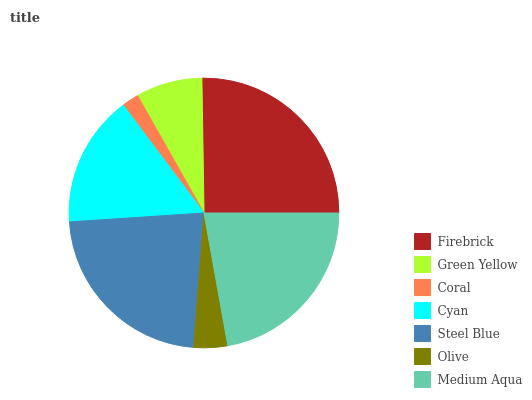Is Coral the minimum?
Answer yes or no. Yes. Is Firebrick the maximum?
Answer yes or no. Yes. Is Green Yellow the minimum?
Answer yes or no. No. Is Green Yellow the maximum?
Answer yes or no. No. Is Firebrick greater than Green Yellow?
Answer yes or no. Yes. Is Green Yellow less than Firebrick?
Answer yes or no. Yes. Is Green Yellow greater than Firebrick?
Answer yes or no. No. Is Firebrick less than Green Yellow?
Answer yes or no. No. Is Cyan the high median?
Answer yes or no. Yes. Is Cyan the low median?
Answer yes or no. Yes. Is Olive the high median?
Answer yes or no. No. Is Firebrick the low median?
Answer yes or no. No. 